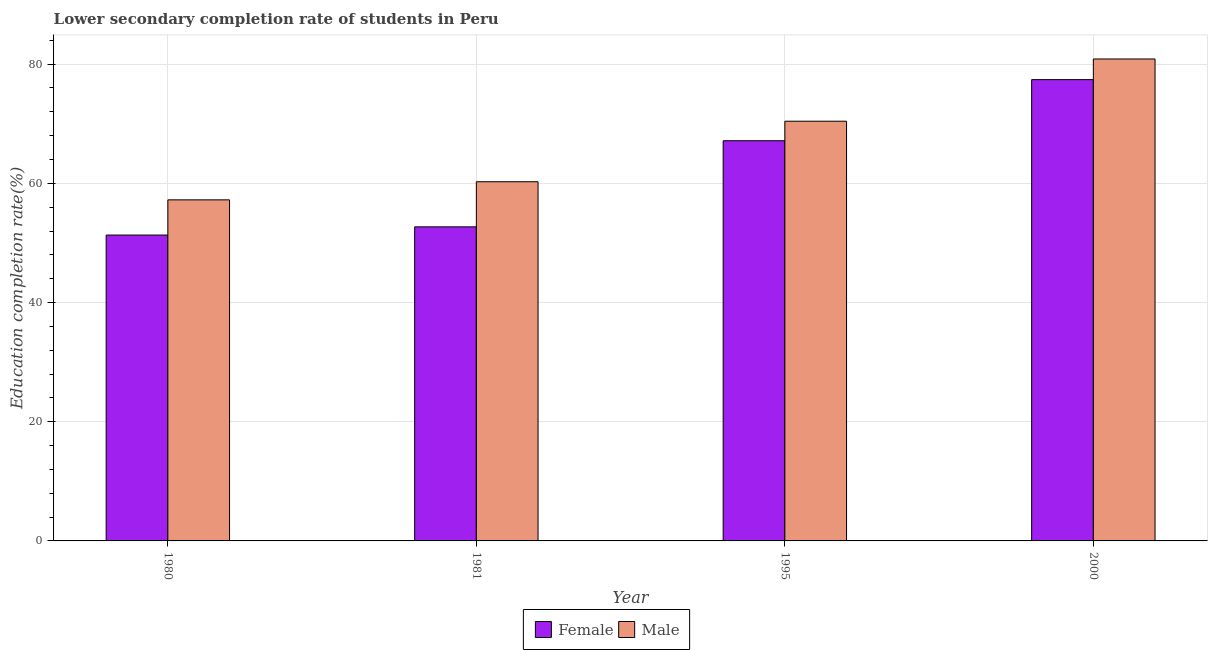How many groups of bars are there?
Your response must be concise. 4. Are the number of bars per tick equal to the number of legend labels?
Your response must be concise. Yes. How many bars are there on the 3rd tick from the left?
Keep it short and to the point. 2. How many bars are there on the 2nd tick from the right?
Offer a very short reply. 2. What is the label of the 4th group of bars from the left?
Your answer should be compact. 2000. In how many cases, is the number of bars for a given year not equal to the number of legend labels?
Ensure brevity in your answer.  0. What is the education completion rate of female students in 1980?
Offer a terse response. 51.32. Across all years, what is the maximum education completion rate of female students?
Keep it short and to the point. 77.4. Across all years, what is the minimum education completion rate of female students?
Offer a very short reply. 51.32. What is the total education completion rate of female students in the graph?
Ensure brevity in your answer.  248.57. What is the difference between the education completion rate of male students in 1995 and that in 2000?
Your answer should be very brief. -10.44. What is the difference between the education completion rate of female students in 1981 and the education completion rate of male students in 2000?
Offer a terse response. -24.7. What is the average education completion rate of male students per year?
Provide a succinct answer. 67.2. What is the ratio of the education completion rate of female students in 1995 to that in 2000?
Provide a short and direct response. 0.87. Is the difference between the education completion rate of male students in 1980 and 1995 greater than the difference between the education completion rate of female students in 1980 and 1995?
Your response must be concise. No. What is the difference between the highest and the second highest education completion rate of male students?
Offer a terse response. 10.44. What is the difference between the highest and the lowest education completion rate of male students?
Offer a terse response. 23.64. Is the sum of the education completion rate of female students in 1980 and 1981 greater than the maximum education completion rate of male students across all years?
Offer a very short reply. Yes. What does the 2nd bar from the right in 1995 represents?
Keep it short and to the point. Female. Are all the bars in the graph horizontal?
Your answer should be compact. No. What is the difference between two consecutive major ticks on the Y-axis?
Make the answer very short. 20. Are the values on the major ticks of Y-axis written in scientific E-notation?
Your answer should be compact. No. Where does the legend appear in the graph?
Your answer should be very brief. Bottom center. How are the legend labels stacked?
Offer a terse response. Horizontal. What is the title of the graph?
Ensure brevity in your answer.  Lower secondary completion rate of students in Peru. What is the label or title of the X-axis?
Provide a succinct answer. Year. What is the label or title of the Y-axis?
Provide a succinct answer. Education completion rate(%). What is the Education completion rate(%) in Female in 1980?
Keep it short and to the point. 51.32. What is the Education completion rate(%) of Male in 1980?
Offer a terse response. 57.23. What is the Education completion rate(%) in Female in 1981?
Your answer should be compact. 52.7. What is the Education completion rate(%) of Male in 1981?
Your answer should be very brief. 60.27. What is the Education completion rate(%) of Female in 1995?
Provide a succinct answer. 67.15. What is the Education completion rate(%) of Male in 1995?
Keep it short and to the point. 70.42. What is the Education completion rate(%) of Female in 2000?
Make the answer very short. 77.4. What is the Education completion rate(%) of Male in 2000?
Your answer should be compact. 80.87. Across all years, what is the maximum Education completion rate(%) in Female?
Provide a short and direct response. 77.4. Across all years, what is the maximum Education completion rate(%) of Male?
Give a very brief answer. 80.87. Across all years, what is the minimum Education completion rate(%) in Female?
Ensure brevity in your answer.  51.32. Across all years, what is the minimum Education completion rate(%) of Male?
Your response must be concise. 57.23. What is the total Education completion rate(%) of Female in the graph?
Keep it short and to the point. 248.57. What is the total Education completion rate(%) of Male in the graph?
Keep it short and to the point. 268.79. What is the difference between the Education completion rate(%) of Female in 1980 and that in 1981?
Your answer should be very brief. -1.38. What is the difference between the Education completion rate(%) in Male in 1980 and that in 1981?
Ensure brevity in your answer.  -3.04. What is the difference between the Education completion rate(%) in Female in 1980 and that in 1995?
Your response must be concise. -15.83. What is the difference between the Education completion rate(%) in Male in 1980 and that in 1995?
Your answer should be very brief. -13.2. What is the difference between the Education completion rate(%) in Female in 1980 and that in 2000?
Provide a short and direct response. -26.08. What is the difference between the Education completion rate(%) in Male in 1980 and that in 2000?
Make the answer very short. -23.64. What is the difference between the Education completion rate(%) in Female in 1981 and that in 1995?
Offer a terse response. -14.45. What is the difference between the Education completion rate(%) of Male in 1981 and that in 1995?
Offer a very short reply. -10.16. What is the difference between the Education completion rate(%) in Female in 1981 and that in 2000?
Keep it short and to the point. -24.7. What is the difference between the Education completion rate(%) in Male in 1981 and that in 2000?
Give a very brief answer. -20.6. What is the difference between the Education completion rate(%) in Female in 1995 and that in 2000?
Give a very brief answer. -10.25. What is the difference between the Education completion rate(%) in Male in 1995 and that in 2000?
Your response must be concise. -10.44. What is the difference between the Education completion rate(%) of Female in 1980 and the Education completion rate(%) of Male in 1981?
Offer a very short reply. -8.95. What is the difference between the Education completion rate(%) of Female in 1980 and the Education completion rate(%) of Male in 1995?
Ensure brevity in your answer.  -19.1. What is the difference between the Education completion rate(%) of Female in 1980 and the Education completion rate(%) of Male in 2000?
Ensure brevity in your answer.  -29.54. What is the difference between the Education completion rate(%) of Female in 1981 and the Education completion rate(%) of Male in 1995?
Provide a succinct answer. -17.73. What is the difference between the Education completion rate(%) of Female in 1981 and the Education completion rate(%) of Male in 2000?
Make the answer very short. -28.17. What is the difference between the Education completion rate(%) of Female in 1995 and the Education completion rate(%) of Male in 2000?
Make the answer very short. -13.72. What is the average Education completion rate(%) in Female per year?
Your response must be concise. 62.14. What is the average Education completion rate(%) in Male per year?
Provide a short and direct response. 67.2. In the year 1980, what is the difference between the Education completion rate(%) in Female and Education completion rate(%) in Male?
Ensure brevity in your answer.  -5.91. In the year 1981, what is the difference between the Education completion rate(%) of Female and Education completion rate(%) of Male?
Your answer should be compact. -7.57. In the year 1995, what is the difference between the Education completion rate(%) of Female and Education completion rate(%) of Male?
Give a very brief answer. -3.27. In the year 2000, what is the difference between the Education completion rate(%) in Female and Education completion rate(%) in Male?
Ensure brevity in your answer.  -3.47. What is the ratio of the Education completion rate(%) in Female in 1980 to that in 1981?
Provide a short and direct response. 0.97. What is the ratio of the Education completion rate(%) in Male in 1980 to that in 1981?
Ensure brevity in your answer.  0.95. What is the ratio of the Education completion rate(%) of Female in 1980 to that in 1995?
Offer a terse response. 0.76. What is the ratio of the Education completion rate(%) of Male in 1980 to that in 1995?
Offer a very short reply. 0.81. What is the ratio of the Education completion rate(%) of Female in 1980 to that in 2000?
Provide a short and direct response. 0.66. What is the ratio of the Education completion rate(%) of Male in 1980 to that in 2000?
Your answer should be compact. 0.71. What is the ratio of the Education completion rate(%) of Female in 1981 to that in 1995?
Offer a terse response. 0.78. What is the ratio of the Education completion rate(%) of Male in 1981 to that in 1995?
Provide a short and direct response. 0.86. What is the ratio of the Education completion rate(%) in Female in 1981 to that in 2000?
Keep it short and to the point. 0.68. What is the ratio of the Education completion rate(%) in Male in 1981 to that in 2000?
Offer a terse response. 0.75. What is the ratio of the Education completion rate(%) in Female in 1995 to that in 2000?
Keep it short and to the point. 0.87. What is the ratio of the Education completion rate(%) of Male in 1995 to that in 2000?
Your answer should be very brief. 0.87. What is the difference between the highest and the second highest Education completion rate(%) of Female?
Offer a very short reply. 10.25. What is the difference between the highest and the second highest Education completion rate(%) of Male?
Make the answer very short. 10.44. What is the difference between the highest and the lowest Education completion rate(%) of Female?
Keep it short and to the point. 26.08. What is the difference between the highest and the lowest Education completion rate(%) in Male?
Ensure brevity in your answer.  23.64. 